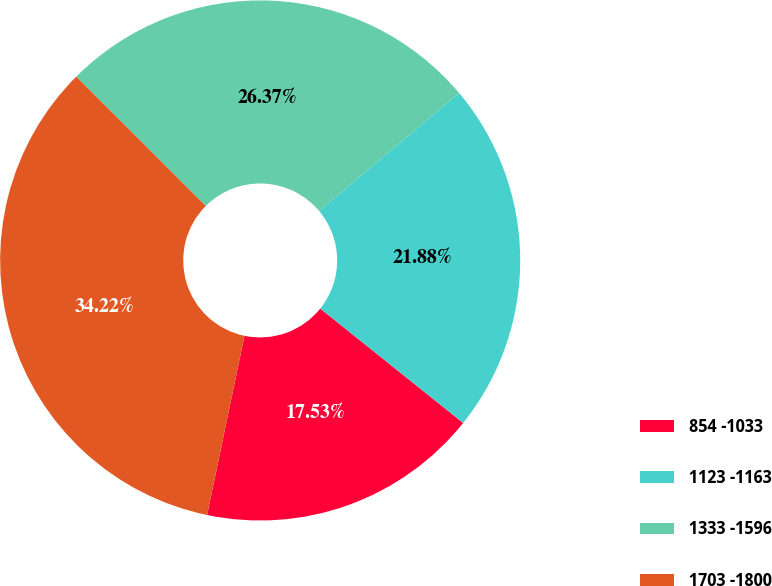Convert chart. <chart><loc_0><loc_0><loc_500><loc_500><pie_chart><fcel>854 -1033<fcel>1123 -1163<fcel>1333 -1596<fcel>1703 -1800<nl><fcel>17.53%<fcel>21.88%<fcel>26.37%<fcel>34.22%<nl></chart> 